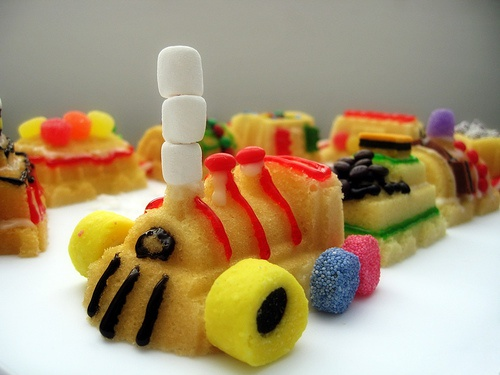Describe the objects in this image and their specific colors. I can see train in gray, olive, and black tones, cake in gray, olive, black, and orange tones, cake in gray, red, orange, and tan tones, cake in gray, olive, black, and darkgreen tones, and cake in gray, olive, tan, and maroon tones in this image. 